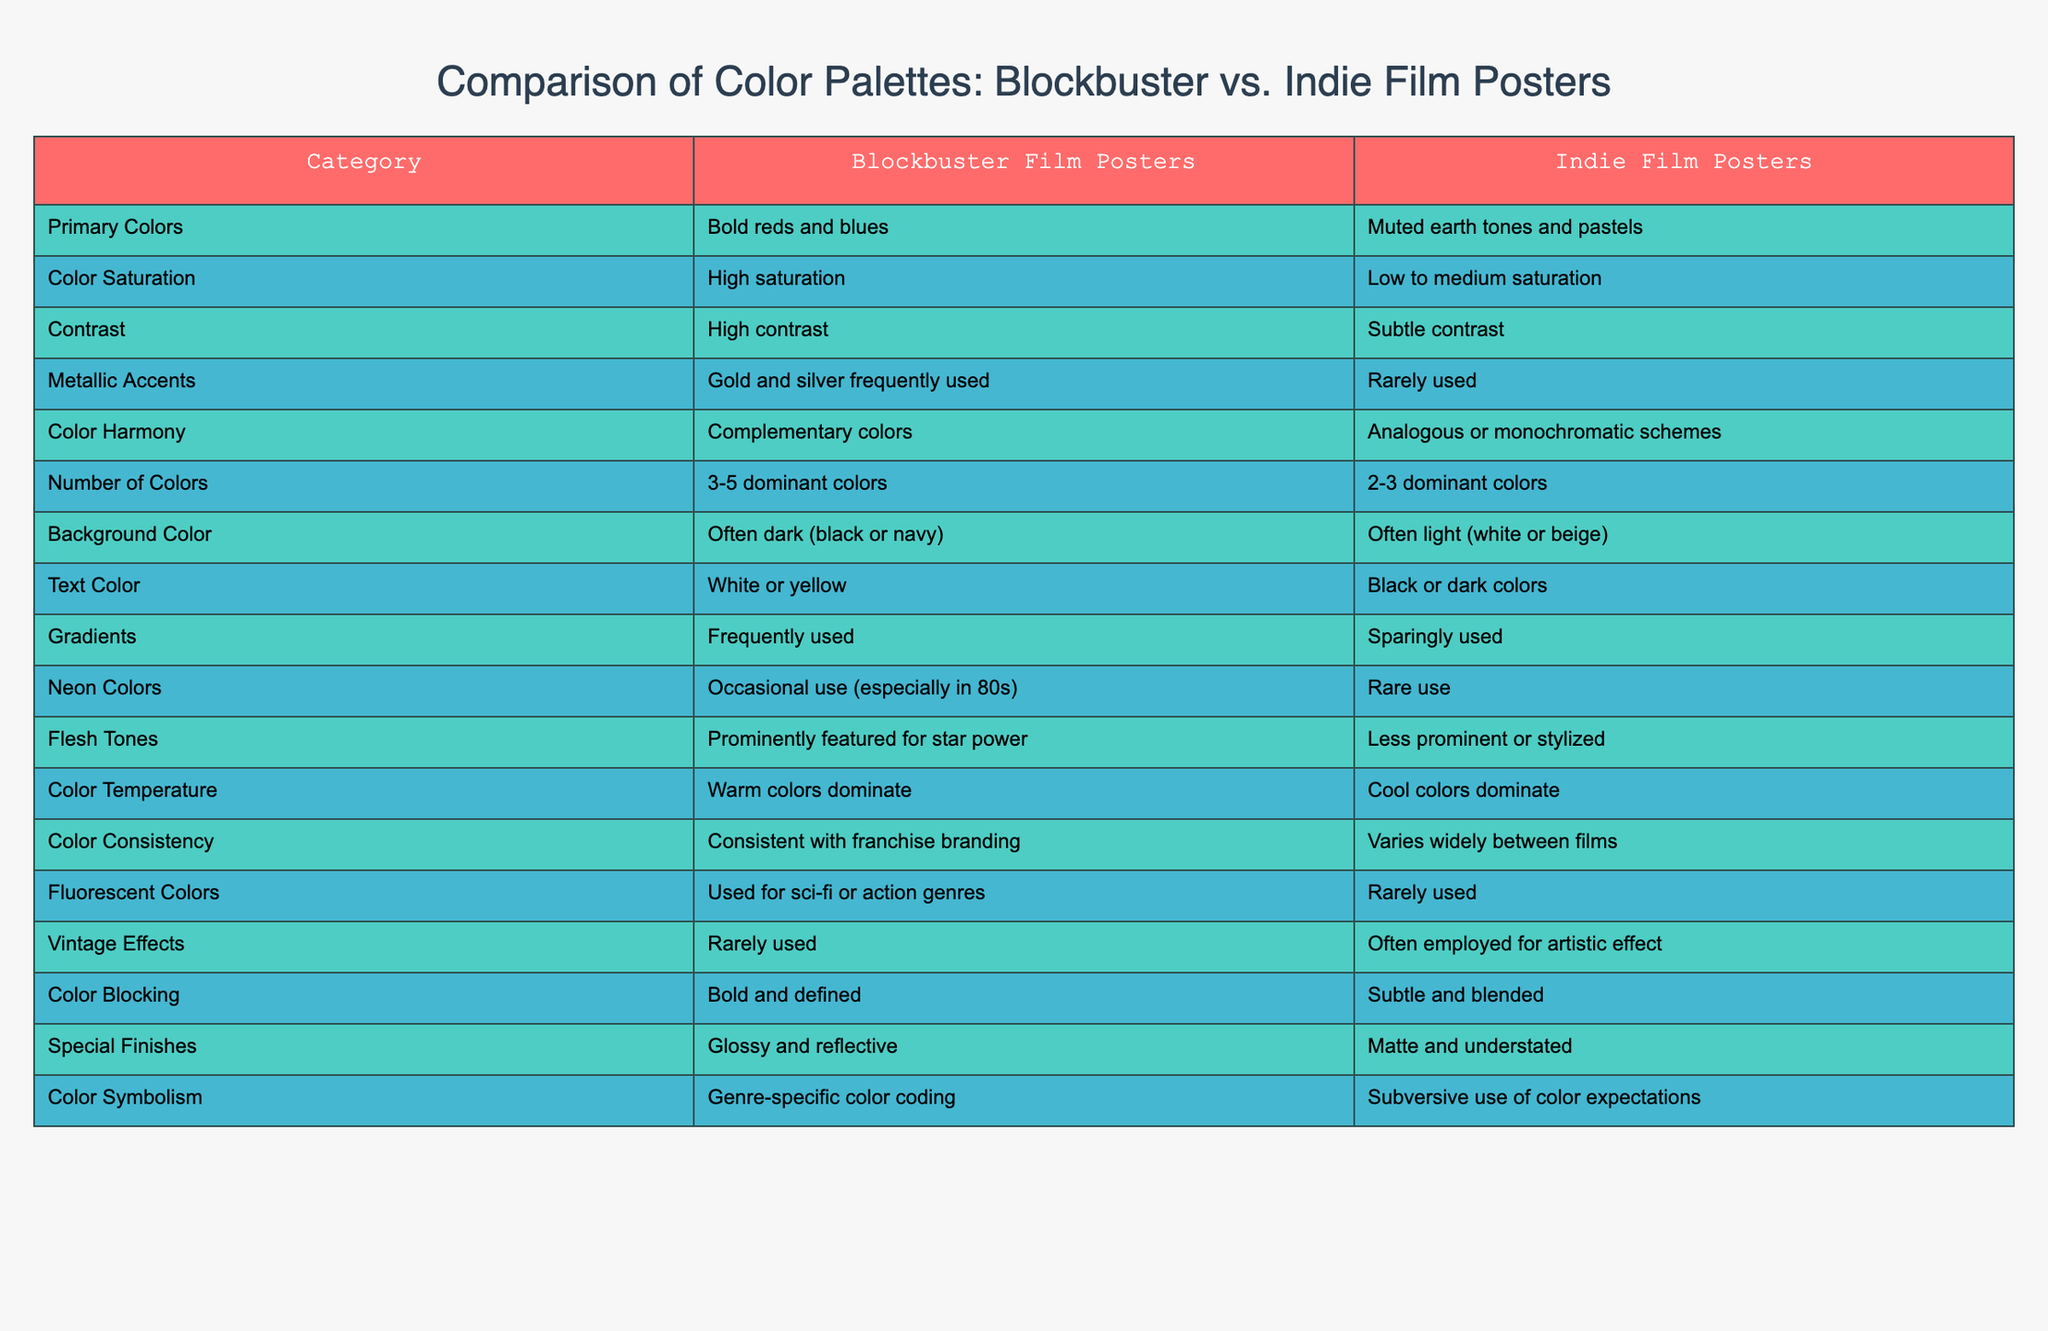What are the primary colors used in blockbuster film posters? According to the table, the primary colors for blockbuster film posters are bold reds and blues. This is a direct retrieval question based on the specific value found in the table under that row.
Answer: Bold reds and blues How many dominant colors are used in indie film posters? The table indicates that indie film posters typically use 2-3 dominant colors. This is straightforward to answer by locating the relevant cell in the "Number of Colors" row for indie film posters.
Answer: 2-3 dominant colors Do indie film posters frequently use metallic accents? The table states that metallic accents are rarely used in indie film posters. This is a fact-based question that can be answered by checking the relevant row in the table.
Answer: No What is the difference in color saturation between blockbuster and indie film posters? The table shows that blockbuster film posters have high saturation while indie film posters have low to medium saturation. Thus, the difference can be noted as blockbuster posters are vibrant whereas indie posters are more subdued.
Answer: Blockbuster: high saturation, Indie: low to medium saturation What color temperature dominates indie film posters compared to blockbuster posters? The table lists that warm colors dominate in blockbuster film posters, while cool colors dominate in indie film posters. This contrast highlights a key stylistic difference where blockbuster posters are more vibrant and energetic relative to the cooler tones in indie posters.
Answer: Blockbuster: warm colors, Indie: cool colors Are gradients used more frequently in blockbuster film posters than in indie film posters? Yes, the table specifies that gradients are frequently used in blockbuster film posters, while they are sparingly used in indie film posters. Thus, this corresponds to a straightforward yes/no question based on direct comparison.
Answer: Yes What color harmony is preferred in indie film posters compared to blockbuster film posters? The table indicates that indie film posters favor analogous or monochromatic schemes, while blockbuster posters utilize complementary colors. Therefore, the preferred style in indie posters is more subtle and cohesive, contrasting with the more vibrant and contrasting harmony in blockbuster posters.
Answer: Indie: analogous or monochromatic, Blockbuster: complementary colors Calculate the average number of dominant colors used in both types of film posters. Blockbuster film posters use 3-5 dominant colors, while indie film posters use 2-3 dominant colors. To find the average, consider the midpoints: 4 for blockbuster (average of 3 and 5) and 2.5 for indie (average of 2 and 3). The overall average would be (4 + 2.5) / 2 = 3.25. This requires calculating the average value based on the provided ranges.
Answer: 3.25 Do blockbuster film posters use vintage effects? The table directly states that vintage effects are rarely used in blockbuster film posters. This is a fact-based question that is easily answered by directly checking the table.
Answer: No 